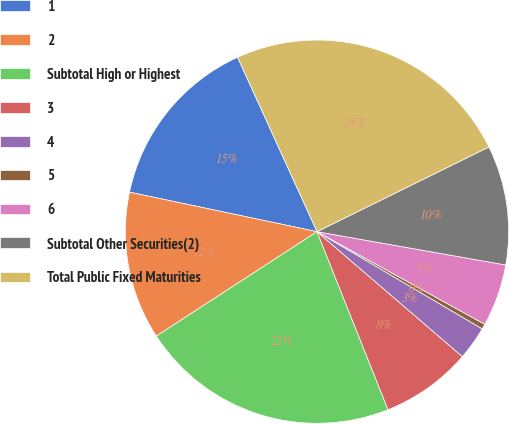<chart> <loc_0><loc_0><loc_500><loc_500><pie_chart><fcel>1<fcel>2<fcel>Subtotal High or Highest<fcel>3<fcel>4<fcel>5<fcel>6<fcel>Subtotal Other Securities(2)<fcel>Total Public Fixed Maturities<nl><fcel>14.89%<fcel>12.48%<fcel>21.87%<fcel>7.66%<fcel>2.84%<fcel>0.43%<fcel>5.25%<fcel>10.07%<fcel>24.52%<nl></chart> 